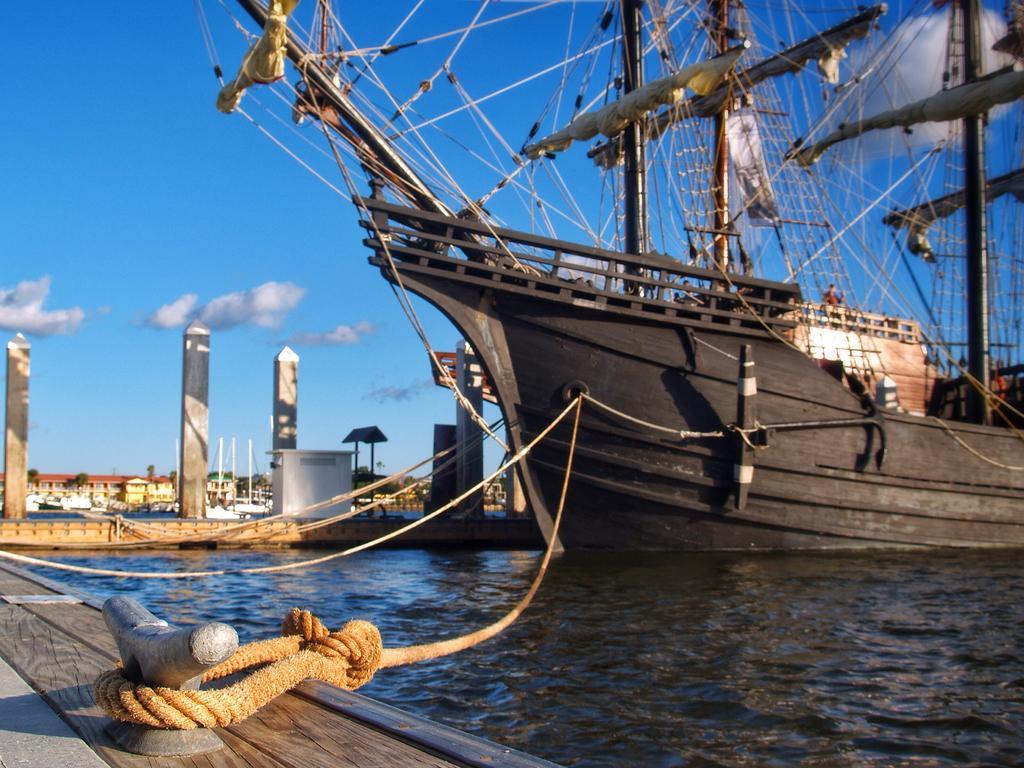How would you summarize this image in a sentence or two? In this image there is a ship on the river and it is connected with ropes, behind that there is a bridge with some objects and pillars on it. In the background there are buildings and the sky. 